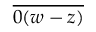<formula> <loc_0><loc_0><loc_500><loc_500>\overline { 0 ( w - z ) }</formula> 